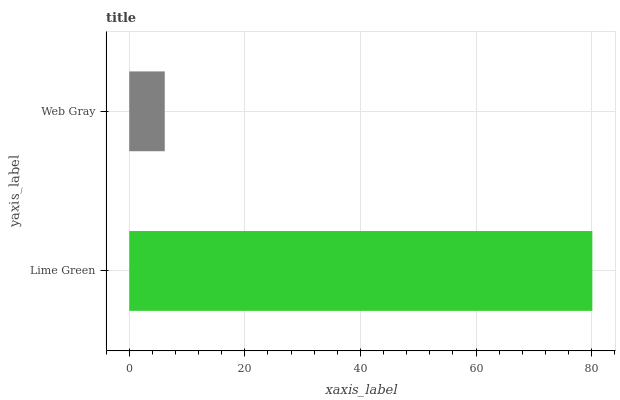Is Web Gray the minimum?
Answer yes or no. Yes. Is Lime Green the maximum?
Answer yes or no. Yes. Is Web Gray the maximum?
Answer yes or no. No. Is Lime Green greater than Web Gray?
Answer yes or no. Yes. Is Web Gray less than Lime Green?
Answer yes or no. Yes. Is Web Gray greater than Lime Green?
Answer yes or no. No. Is Lime Green less than Web Gray?
Answer yes or no. No. Is Lime Green the high median?
Answer yes or no. Yes. Is Web Gray the low median?
Answer yes or no. Yes. Is Web Gray the high median?
Answer yes or no. No. Is Lime Green the low median?
Answer yes or no. No. 